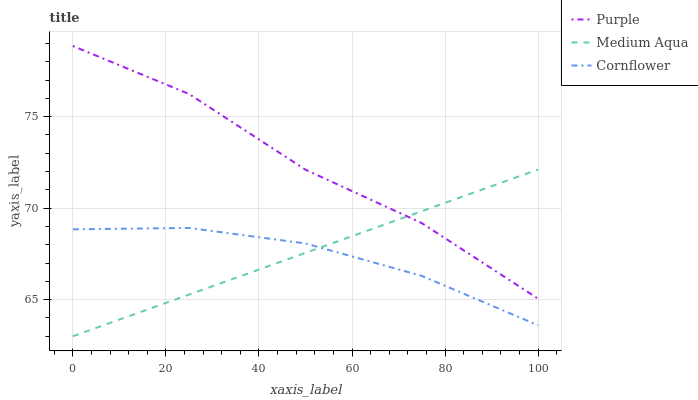Does Cornflower have the minimum area under the curve?
Answer yes or no. Yes. Does Purple have the maximum area under the curve?
Answer yes or no. Yes. Does Medium Aqua have the minimum area under the curve?
Answer yes or no. No. Does Medium Aqua have the maximum area under the curve?
Answer yes or no. No. Is Medium Aqua the smoothest?
Answer yes or no. Yes. Is Purple the roughest?
Answer yes or no. Yes. Is Cornflower the smoothest?
Answer yes or no. No. Is Cornflower the roughest?
Answer yes or no. No. Does Medium Aqua have the lowest value?
Answer yes or no. Yes. Does Cornflower have the lowest value?
Answer yes or no. No. Does Purple have the highest value?
Answer yes or no. Yes. Does Medium Aqua have the highest value?
Answer yes or no. No. Is Cornflower less than Purple?
Answer yes or no. Yes. Is Purple greater than Cornflower?
Answer yes or no. Yes. Does Medium Aqua intersect Cornflower?
Answer yes or no. Yes. Is Medium Aqua less than Cornflower?
Answer yes or no. No. Is Medium Aqua greater than Cornflower?
Answer yes or no. No. Does Cornflower intersect Purple?
Answer yes or no. No. 